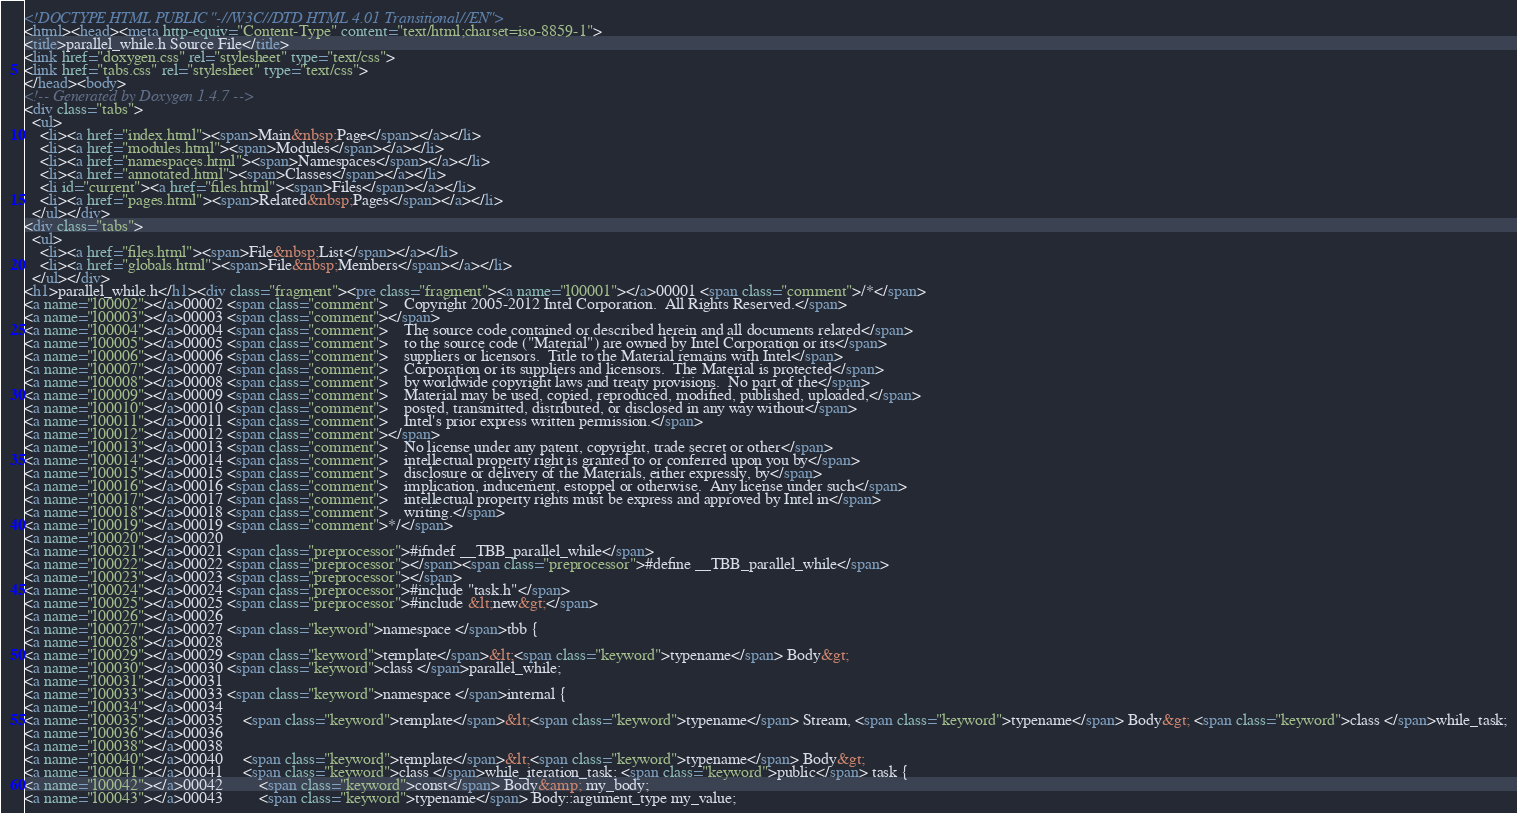Convert code to text. <code><loc_0><loc_0><loc_500><loc_500><_HTML_><!DOCTYPE HTML PUBLIC "-//W3C//DTD HTML 4.01 Transitional//EN">
<html><head><meta http-equiv="Content-Type" content="text/html;charset=iso-8859-1">
<title>parallel_while.h Source File</title>
<link href="doxygen.css" rel="stylesheet" type="text/css">
<link href="tabs.css" rel="stylesheet" type="text/css">
</head><body>
<!-- Generated by Doxygen 1.4.7 -->
<div class="tabs">
  <ul>
    <li><a href="index.html"><span>Main&nbsp;Page</span></a></li>
    <li><a href="modules.html"><span>Modules</span></a></li>
    <li><a href="namespaces.html"><span>Namespaces</span></a></li>
    <li><a href="annotated.html"><span>Classes</span></a></li>
    <li id="current"><a href="files.html"><span>Files</span></a></li>
    <li><a href="pages.html"><span>Related&nbsp;Pages</span></a></li>
  </ul></div>
<div class="tabs">
  <ul>
    <li><a href="files.html"><span>File&nbsp;List</span></a></li>
    <li><a href="globals.html"><span>File&nbsp;Members</span></a></li>
  </ul></div>
<h1>parallel_while.h</h1><div class="fragment"><pre class="fragment"><a name="l00001"></a>00001 <span class="comment">/*</span>
<a name="l00002"></a>00002 <span class="comment">    Copyright 2005-2012 Intel Corporation.  All Rights Reserved.</span>
<a name="l00003"></a>00003 <span class="comment"></span>
<a name="l00004"></a>00004 <span class="comment">    The source code contained or described herein and all documents related</span>
<a name="l00005"></a>00005 <span class="comment">    to the source code ("Material") are owned by Intel Corporation or its</span>
<a name="l00006"></a>00006 <span class="comment">    suppliers or licensors.  Title to the Material remains with Intel</span>
<a name="l00007"></a>00007 <span class="comment">    Corporation or its suppliers and licensors.  The Material is protected</span>
<a name="l00008"></a>00008 <span class="comment">    by worldwide copyright laws and treaty provisions.  No part of the</span>
<a name="l00009"></a>00009 <span class="comment">    Material may be used, copied, reproduced, modified, published, uploaded,</span>
<a name="l00010"></a>00010 <span class="comment">    posted, transmitted, distributed, or disclosed in any way without</span>
<a name="l00011"></a>00011 <span class="comment">    Intel's prior express written permission.</span>
<a name="l00012"></a>00012 <span class="comment"></span>
<a name="l00013"></a>00013 <span class="comment">    No license under any patent, copyright, trade secret or other</span>
<a name="l00014"></a>00014 <span class="comment">    intellectual property right is granted to or conferred upon you by</span>
<a name="l00015"></a>00015 <span class="comment">    disclosure or delivery of the Materials, either expressly, by</span>
<a name="l00016"></a>00016 <span class="comment">    implication, inducement, estoppel or otherwise.  Any license under such</span>
<a name="l00017"></a>00017 <span class="comment">    intellectual property rights must be express and approved by Intel in</span>
<a name="l00018"></a>00018 <span class="comment">    writing.</span>
<a name="l00019"></a>00019 <span class="comment">*/</span>
<a name="l00020"></a>00020 
<a name="l00021"></a>00021 <span class="preprocessor">#ifndef __TBB_parallel_while</span>
<a name="l00022"></a>00022 <span class="preprocessor"></span><span class="preprocessor">#define __TBB_parallel_while</span>
<a name="l00023"></a>00023 <span class="preprocessor"></span>
<a name="l00024"></a>00024 <span class="preprocessor">#include "task.h"</span>
<a name="l00025"></a>00025 <span class="preprocessor">#include &lt;new&gt;</span>
<a name="l00026"></a>00026 
<a name="l00027"></a>00027 <span class="keyword">namespace </span>tbb {
<a name="l00028"></a>00028 
<a name="l00029"></a>00029 <span class="keyword">template</span>&lt;<span class="keyword">typename</span> Body&gt;
<a name="l00030"></a>00030 <span class="keyword">class </span>parallel_while;
<a name="l00031"></a>00031 
<a name="l00033"></a>00033 <span class="keyword">namespace </span>internal {
<a name="l00034"></a>00034 
<a name="l00035"></a>00035     <span class="keyword">template</span>&lt;<span class="keyword">typename</span> Stream, <span class="keyword">typename</span> Body&gt; <span class="keyword">class </span>while_task;
<a name="l00036"></a>00036 
<a name="l00038"></a>00038 
<a name="l00040"></a>00040     <span class="keyword">template</span>&lt;<span class="keyword">typename</span> Body&gt;
<a name="l00041"></a>00041     <span class="keyword">class </span>while_iteration_task: <span class="keyword">public</span> task {
<a name="l00042"></a>00042         <span class="keyword">const</span> Body&amp; my_body;
<a name="l00043"></a>00043         <span class="keyword">typename</span> Body::argument_type my_value;</code> 